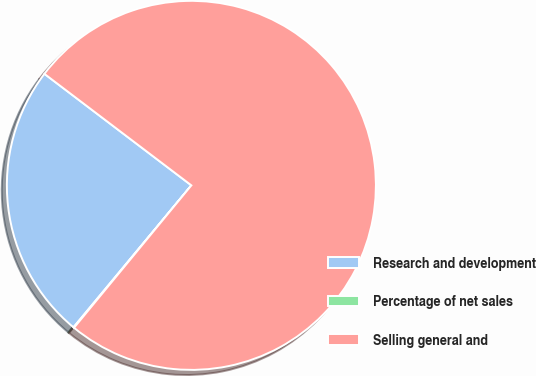Convert chart to OTSL. <chart><loc_0><loc_0><loc_500><loc_500><pie_chart><fcel>Research and development<fcel>Percentage of net sales<fcel>Selling general and<nl><fcel>24.3%<fcel>0.06%<fcel>75.64%<nl></chart> 